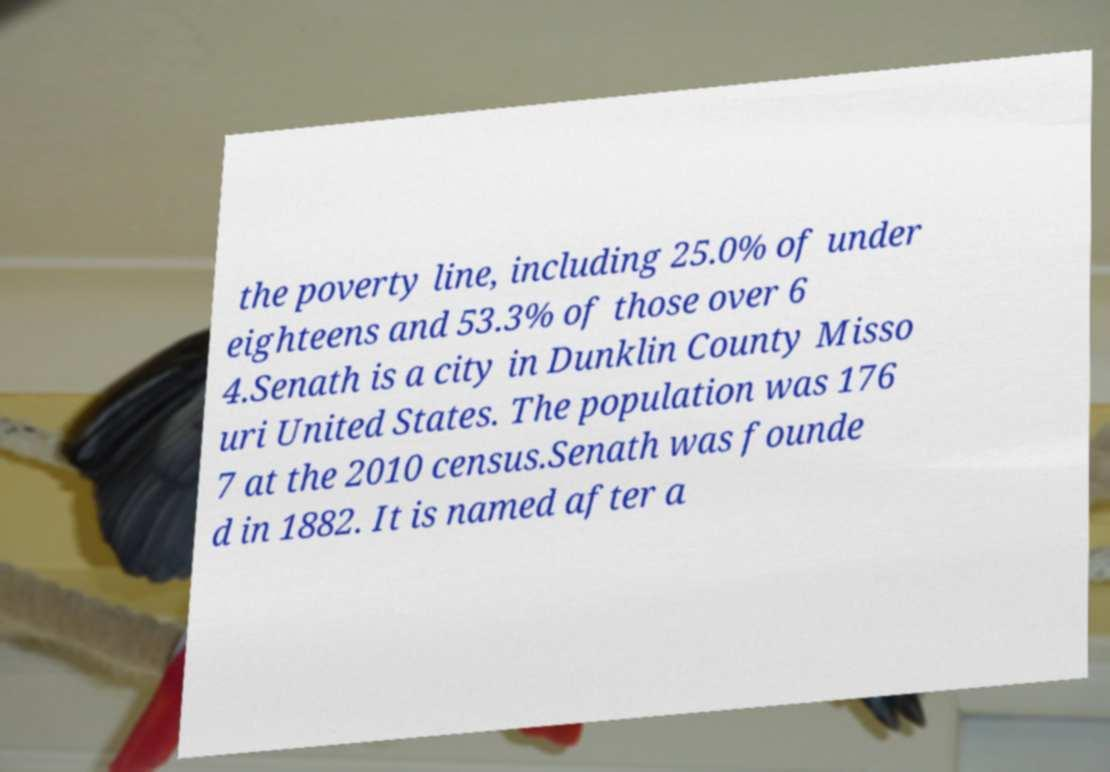Could you assist in decoding the text presented in this image and type it out clearly? the poverty line, including 25.0% of under eighteens and 53.3% of those over 6 4.Senath is a city in Dunklin County Misso uri United States. The population was 176 7 at the 2010 census.Senath was founde d in 1882. It is named after a 